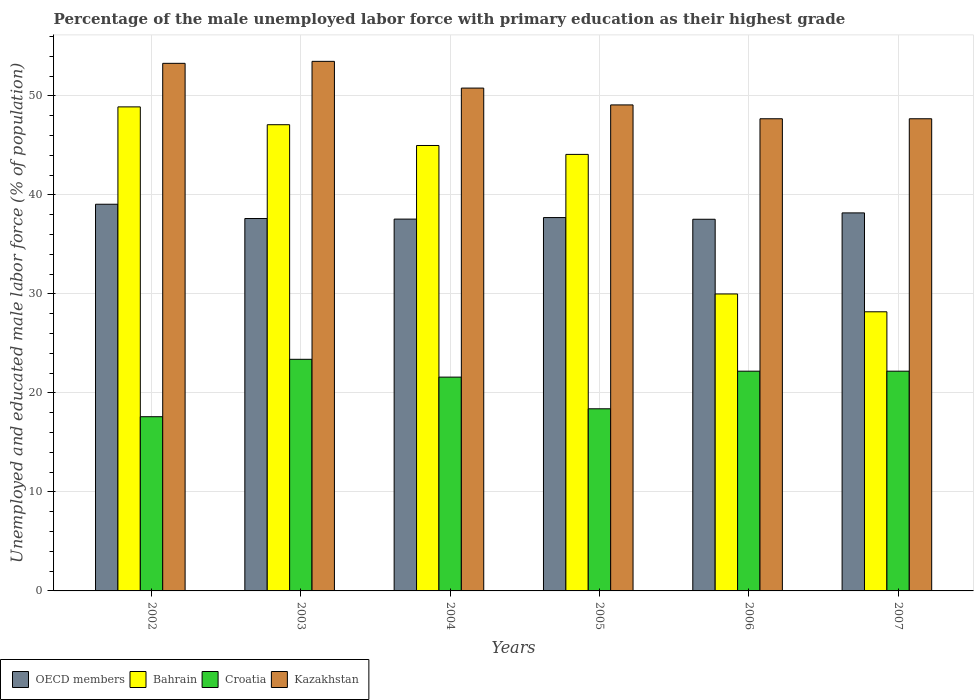How many groups of bars are there?
Your answer should be compact. 6. Are the number of bars per tick equal to the number of legend labels?
Your response must be concise. Yes. How many bars are there on the 6th tick from the left?
Provide a succinct answer. 4. How many bars are there on the 4th tick from the right?
Provide a succinct answer. 4. What is the label of the 2nd group of bars from the left?
Make the answer very short. 2003. What is the percentage of the unemployed male labor force with primary education in Kazakhstan in 2006?
Provide a short and direct response. 47.7. Across all years, what is the maximum percentage of the unemployed male labor force with primary education in Bahrain?
Give a very brief answer. 48.9. Across all years, what is the minimum percentage of the unemployed male labor force with primary education in Kazakhstan?
Your answer should be compact. 47.7. In which year was the percentage of the unemployed male labor force with primary education in Bahrain minimum?
Offer a very short reply. 2007. What is the total percentage of the unemployed male labor force with primary education in OECD members in the graph?
Ensure brevity in your answer.  227.71. What is the difference between the percentage of the unemployed male labor force with primary education in Bahrain in 2006 and that in 2007?
Provide a succinct answer. 1.8. What is the difference between the percentage of the unemployed male labor force with primary education in Bahrain in 2007 and the percentage of the unemployed male labor force with primary education in Kazakhstan in 2002?
Ensure brevity in your answer.  -25.1. What is the average percentage of the unemployed male labor force with primary education in Croatia per year?
Make the answer very short. 20.9. In the year 2003, what is the difference between the percentage of the unemployed male labor force with primary education in Kazakhstan and percentage of the unemployed male labor force with primary education in Bahrain?
Give a very brief answer. 6.4. In how many years, is the percentage of the unemployed male labor force with primary education in Kazakhstan greater than 2 %?
Provide a succinct answer. 6. What is the ratio of the percentage of the unemployed male labor force with primary education in Bahrain in 2004 to that in 2005?
Keep it short and to the point. 1.02. Is the percentage of the unemployed male labor force with primary education in Croatia in 2004 less than that in 2007?
Offer a terse response. Yes. Is the difference between the percentage of the unemployed male labor force with primary education in Kazakhstan in 2002 and 2005 greater than the difference between the percentage of the unemployed male labor force with primary education in Bahrain in 2002 and 2005?
Your answer should be compact. No. What is the difference between the highest and the second highest percentage of the unemployed male labor force with primary education in Croatia?
Offer a terse response. 1.2. What is the difference between the highest and the lowest percentage of the unemployed male labor force with primary education in Croatia?
Offer a terse response. 5.8. Is the sum of the percentage of the unemployed male labor force with primary education in Bahrain in 2004 and 2005 greater than the maximum percentage of the unemployed male labor force with primary education in Kazakhstan across all years?
Offer a terse response. Yes. Is it the case that in every year, the sum of the percentage of the unemployed male labor force with primary education in OECD members and percentage of the unemployed male labor force with primary education in Bahrain is greater than the sum of percentage of the unemployed male labor force with primary education in Kazakhstan and percentage of the unemployed male labor force with primary education in Croatia?
Offer a very short reply. No. What does the 4th bar from the left in 2002 represents?
Provide a succinct answer. Kazakhstan. What does the 1st bar from the right in 2006 represents?
Provide a succinct answer. Kazakhstan. Is it the case that in every year, the sum of the percentage of the unemployed male labor force with primary education in Croatia and percentage of the unemployed male labor force with primary education in Bahrain is greater than the percentage of the unemployed male labor force with primary education in OECD members?
Give a very brief answer. Yes. How many years are there in the graph?
Your response must be concise. 6. What is the difference between two consecutive major ticks on the Y-axis?
Offer a terse response. 10. Are the values on the major ticks of Y-axis written in scientific E-notation?
Make the answer very short. No. Does the graph contain grids?
Provide a short and direct response. Yes. How many legend labels are there?
Your answer should be very brief. 4. How are the legend labels stacked?
Keep it short and to the point. Horizontal. What is the title of the graph?
Ensure brevity in your answer.  Percentage of the male unemployed labor force with primary education as their highest grade. What is the label or title of the X-axis?
Offer a very short reply. Years. What is the label or title of the Y-axis?
Make the answer very short. Unemployed and educated male labor force (% of population). What is the Unemployed and educated male labor force (% of population) in OECD members in 2002?
Offer a very short reply. 39.06. What is the Unemployed and educated male labor force (% of population) in Bahrain in 2002?
Offer a very short reply. 48.9. What is the Unemployed and educated male labor force (% of population) in Croatia in 2002?
Ensure brevity in your answer.  17.6. What is the Unemployed and educated male labor force (% of population) of Kazakhstan in 2002?
Provide a succinct answer. 53.3. What is the Unemployed and educated male labor force (% of population) in OECD members in 2003?
Provide a short and direct response. 37.62. What is the Unemployed and educated male labor force (% of population) of Bahrain in 2003?
Offer a very short reply. 47.1. What is the Unemployed and educated male labor force (% of population) of Croatia in 2003?
Your answer should be compact. 23.4. What is the Unemployed and educated male labor force (% of population) in Kazakhstan in 2003?
Your answer should be very brief. 53.5. What is the Unemployed and educated male labor force (% of population) in OECD members in 2004?
Make the answer very short. 37.56. What is the Unemployed and educated male labor force (% of population) of Croatia in 2004?
Your response must be concise. 21.6. What is the Unemployed and educated male labor force (% of population) in Kazakhstan in 2004?
Offer a very short reply. 50.8. What is the Unemployed and educated male labor force (% of population) in OECD members in 2005?
Provide a short and direct response. 37.72. What is the Unemployed and educated male labor force (% of population) of Bahrain in 2005?
Your answer should be very brief. 44.1. What is the Unemployed and educated male labor force (% of population) of Croatia in 2005?
Provide a succinct answer. 18.4. What is the Unemployed and educated male labor force (% of population) in Kazakhstan in 2005?
Offer a terse response. 49.1. What is the Unemployed and educated male labor force (% of population) of OECD members in 2006?
Keep it short and to the point. 37.55. What is the Unemployed and educated male labor force (% of population) of Croatia in 2006?
Ensure brevity in your answer.  22.2. What is the Unemployed and educated male labor force (% of population) in Kazakhstan in 2006?
Your answer should be compact. 47.7. What is the Unemployed and educated male labor force (% of population) in OECD members in 2007?
Provide a short and direct response. 38.19. What is the Unemployed and educated male labor force (% of population) in Bahrain in 2007?
Provide a succinct answer. 28.2. What is the Unemployed and educated male labor force (% of population) of Croatia in 2007?
Keep it short and to the point. 22.2. What is the Unemployed and educated male labor force (% of population) in Kazakhstan in 2007?
Keep it short and to the point. 47.7. Across all years, what is the maximum Unemployed and educated male labor force (% of population) in OECD members?
Ensure brevity in your answer.  39.06. Across all years, what is the maximum Unemployed and educated male labor force (% of population) in Bahrain?
Your answer should be very brief. 48.9. Across all years, what is the maximum Unemployed and educated male labor force (% of population) in Croatia?
Make the answer very short. 23.4. Across all years, what is the maximum Unemployed and educated male labor force (% of population) in Kazakhstan?
Make the answer very short. 53.5. Across all years, what is the minimum Unemployed and educated male labor force (% of population) of OECD members?
Ensure brevity in your answer.  37.55. Across all years, what is the minimum Unemployed and educated male labor force (% of population) of Bahrain?
Your answer should be compact. 28.2. Across all years, what is the minimum Unemployed and educated male labor force (% of population) of Croatia?
Make the answer very short. 17.6. Across all years, what is the minimum Unemployed and educated male labor force (% of population) of Kazakhstan?
Give a very brief answer. 47.7. What is the total Unemployed and educated male labor force (% of population) of OECD members in the graph?
Make the answer very short. 227.71. What is the total Unemployed and educated male labor force (% of population) in Bahrain in the graph?
Your answer should be very brief. 243.3. What is the total Unemployed and educated male labor force (% of population) in Croatia in the graph?
Keep it short and to the point. 125.4. What is the total Unemployed and educated male labor force (% of population) in Kazakhstan in the graph?
Offer a terse response. 302.1. What is the difference between the Unemployed and educated male labor force (% of population) of OECD members in 2002 and that in 2003?
Your answer should be compact. 1.44. What is the difference between the Unemployed and educated male labor force (% of population) in Bahrain in 2002 and that in 2003?
Your answer should be very brief. 1.8. What is the difference between the Unemployed and educated male labor force (% of population) in OECD members in 2002 and that in 2004?
Your answer should be very brief. 1.5. What is the difference between the Unemployed and educated male labor force (% of population) of Croatia in 2002 and that in 2004?
Your answer should be compact. -4. What is the difference between the Unemployed and educated male labor force (% of population) of Kazakhstan in 2002 and that in 2004?
Ensure brevity in your answer.  2.5. What is the difference between the Unemployed and educated male labor force (% of population) in OECD members in 2002 and that in 2005?
Provide a succinct answer. 1.35. What is the difference between the Unemployed and educated male labor force (% of population) of Bahrain in 2002 and that in 2005?
Give a very brief answer. 4.8. What is the difference between the Unemployed and educated male labor force (% of population) of Croatia in 2002 and that in 2005?
Ensure brevity in your answer.  -0.8. What is the difference between the Unemployed and educated male labor force (% of population) in OECD members in 2002 and that in 2006?
Ensure brevity in your answer.  1.52. What is the difference between the Unemployed and educated male labor force (% of population) in Bahrain in 2002 and that in 2006?
Provide a succinct answer. 18.9. What is the difference between the Unemployed and educated male labor force (% of population) of Kazakhstan in 2002 and that in 2006?
Your answer should be compact. 5.6. What is the difference between the Unemployed and educated male labor force (% of population) in OECD members in 2002 and that in 2007?
Ensure brevity in your answer.  0.87. What is the difference between the Unemployed and educated male labor force (% of population) of Bahrain in 2002 and that in 2007?
Provide a succinct answer. 20.7. What is the difference between the Unemployed and educated male labor force (% of population) in Kazakhstan in 2002 and that in 2007?
Give a very brief answer. 5.6. What is the difference between the Unemployed and educated male labor force (% of population) in OECD members in 2003 and that in 2004?
Your answer should be compact. 0.06. What is the difference between the Unemployed and educated male labor force (% of population) of OECD members in 2003 and that in 2005?
Provide a short and direct response. -0.1. What is the difference between the Unemployed and educated male labor force (% of population) in Bahrain in 2003 and that in 2005?
Provide a succinct answer. 3. What is the difference between the Unemployed and educated male labor force (% of population) of OECD members in 2003 and that in 2006?
Keep it short and to the point. 0.07. What is the difference between the Unemployed and educated male labor force (% of population) in Kazakhstan in 2003 and that in 2006?
Offer a terse response. 5.8. What is the difference between the Unemployed and educated male labor force (% of population) in OECD members in 2003 and that in 2007?
Make the answer very short. -0.57. What is the difference between the Unemployed and educated male labor force (% of population) of Bahrain in 2003 and that in 2007?
Provide a short and direct response. 18.9. What is the difference between the Unemployed and educated male labor force (% of population) of OECD members in 2004 and that in 2005?
Keep it short and to the point. -0.16. What is the difference between the Unemployed and educated male labor force (% of population) in OECD members in 2004 and that in 2006?
Offer a terse response. 0.02. What is the difference between the Unemployed and educated male labor force (% of population) in Bahrain in 2004 and that in 2006?
Your answer should be compact. 15. What is the difference between the Unemployed and educated male labor force (% of population) in Kazakhstan in 2004 and that in 2006?
Your answer should be very brief. 3.1. What is the difference between the Unemployed and educated male labor force (% of population) in OECD members in 2004 and that in 2007?
Offer a very short reply. -0.63. What is the difference between the Unemployed and educated male labor force (% of population) in Bahrain in 2004 and that in 2007?
Your answer should be compact. 16.8. What is the difference between the Unemployed and educated male labor force (% of population) in Kazakhstan in 2004 and that in 2007?
Your answer should be compact. 3.1. What is the difference between the Unemployed and educated male labor force (% of population) of OECD members in 2005 and that in 2006?
Offer a very short reply. 0.17. What is the difference between the Unemployed and educated male labor force (% of population) of Bahrain in 2005 and that in 2006?
Provide a short and direct response. 14.1. What is the difference between the Unemployed and educated male labor force (% of population) in Kazakhstan in 2005 and that in 2006?
Your answer should be compact. 1.4. What is the difference between the Unemployed and educated male labor force (% of population) of OECD members in 2005 and that in 2007?
Your answer should be compact. -0.47. What is the difference between the Unemployed and educated male labor force (% of population) of OECD members in 2006 and that in 2007?
Your answer should be very brief. -0.64. What is the difference between the Unemployed and educated male labor force (% of population) of Bahrain in 2006 and that in 2007?
Offer a terse response. 1.8. What is the difference between the Unemployed and educated male labor force (% of population) in Croatia in 2006 and that in 2007?
Ensure brevity in your answer.  0. What is the difference between the Unemployed and educated male labor force (% of population) of Kazakhstan in 2006 and that in 2007?
Offer a very short reply. 0. What is the difference between the Unemployed and educated male labor force (% of population) of OECD members in 2002 and the Unemployed and educated male labor force (% of population) of Bahrain in 2003?
Offer a terse response. -8.04. What is the difference between the Unemployed and educated male labor force (% of population) of OECD members in 2002 and the Unemployed and educated male labor force (% of population) of Croatia in 2003?
Your answer should be very brief. 15.66. What is the difference between the Unemployed and educated male labor force (% of population) of OECD members in 2002 and the Unemployed and educated male labor force (% of population) of Kazakhstan in 2003?
Your answer should be very brief. -14.44. What is the difference between the Unemployed and educated male labor force (% of population) of Bahrain in 2002 and the Unemployed and educated male labor force (% of population) of Kazakhstan in 2003?
Offer a terse response. -4.6. What is the difference between the Unemployed and educated male labor force (% of population) in Croatia in 2002 and the Unemployed and educated male labor force (% of population) in Kazakhstan in 2003?
Offer a very short reply. -35.9. What is the difference between the Unemployed and educated male labor force (% of population) of OECD members in 2002 and the Unemployed and educated male labor force (% of population) of Bahrain in 2004?
Make the answer very short. -5.94. What is the difference between the Unemployed and educated male labor force (% of population) in OECD members in 2002 and the Unemployed and educated male labor force (% of population) in Croatia in 2004?
Your answer should be compact. 17.46. What is the difference between the Unemployed and educated male labor force (% of population) in OECD members in 2002 and the Unemployed and educated male labor force (% of population) in Kazakhstan in 2004?
Give a very brief answer. -11.74. What is the difference between the Unemployed and educated male labor force (% of population) in Bahrain in 2002 and the Unemployed and educated male labor force (% of population) in Croatia in 2004?
Your answer should be compact. 27.3. What is the difference between the Unemployed and educated male labor force (% of population) in Bahrain in 2002 and the Unemployed and educated male labor force (% of population) in Kazakhstan in 2004?
Your answer should be compact. -1.9. What is the difference between the Unemployed and educated male labor force (% of population) of Croatia in 2002 and the Unemployed and educated male labor force (% of population) of Kazakhstan in 2004?
Your response must be concise. -33.2. What is the difference between the Unemployed and educated male labor force (% of population) in OECD members in 2002 and the Unemployed and educated male labor force (% of population) in Bahrain in 2005?
Your answer should be very brief. -5.04. What is the difference between the Unemployed and educated male labor force (% of population) in OECD members in 2002 and the Unemployed and educated male labor force (% of population) in Croatia in 2005?
Provide a succinct answer. 20.66. What is the difference between the Unemployed and educated male labor force (% of population) in OECD members in 2002 and the Unemployed and educated male labor force (% of population) in Kazakhstan in 2005?
Give a very brief answer. -10.04. What is the difference between the Unemployed and educated male labor force (% of population) in Bahrain in 2002 and the Unemployed and educated male labor force (% of population) in Croatia in 2005?
Make the answer very short. 30.5. What is the difference between the Unemployed and educated male labor force (% of population) in Bahrain in 2002 and the Unemployed and educated male labor force (% of population) in Kazakhstan in 2005?
Offer a terse response. -0.2. What is the difference between the Unemployed and educated male labor force (% of population) of Croatia in 2002 and the Unemployed and educated male labor force (% of population) of Kazakhstan in 2005?
Make the answer very short. -31.5. What is the difference between the Unemployed and educated male labor force (% of population) in OECD members in 2002 and the Unemployed and educated male labor force (% of population) in Bahrain in 2006?
Your answer should be very brief. 9.06. What is the difference between the Unemployed and educated male labor force (% of population) of OECD members in 2002 and the Unemployed and educated male labor force (% of population) of Croatia in 2006?
Make the answer very short. 16.86. What is the difference between the Unemployed and educated male labor force (% of population) in OECD members in 2002 and the Unemployed and educated male labor force (% of population) in Kazakhstan in 2006?
Give a very brief answer. -8.64. What is the difference between the Unemployed and educated male labor force (% of population) of Bahrain in 2002 and the Unemployed and educated male labor force (% of population) of Croatia in 2006?
Give a very brief answer. 26.7. What is the difference between the Unemployed and educated male labor force (% of population) of Croatia in 2002 and the Unemployed and educated male labor force (% of population) of Kazakhstan in 2006?
Provide a succinct answer. -30.1. What is the difference between the Unemployed and educated male labor force (% of population) of OECD members in 2002 and the Unemployed and educated male labor force (% of population) of Bahrain in 2007?
Offer a terse response. 10.86. What is the difference between the Unemployed and educated male labor force (% of population) in OECD members in 2002 and the Unemployed and educated male labor force (% of population) in Croatia in 2007?
Your answer should be very brief. 16.86. What is the difference between the Unemployed and educated male labor force (% of population) of OECD members in 2002 and the Unemployed and educated male labor force (% of population) of Kazakhstan in 2007?
Your answer should be very brief. -8.64. What is the difference between the Unemployed and educated male labor force (% of population) of Bahrain in 2002 and the Unemployed and educated male labor force (% of population) of Croatia in 2007?
Make the answer very short. 26.7. What is the difference between the Unemployed and educated male labor force (% of population) of Bahrain in 2002 and the Unemployed and educated male labor force (% of population) of Kazakhstan in 2007?
Make the answer very short. 1.2. What is the difference between the Unemployed and educated male labor force (% of population) of Croatia in 2002 and the Unemployed and educated male labor force (% of population) of Kazakhstan in 2007?
Offer a very short reply. -30.1. What is the difference between the Unemployed and educated male labor force (% of population) in OECD members in 2003 and the Unemployed and educated male labor force (% of population) in Bahrain in 2004?
Provide a short and direct response. -7.38. What is the difference between the Unemployed and educated male labor force (% of population) of OECD members in 2003 and the Unemployed and educated male labor force (% of population) of Croatia in 2004?
Make the answer very short. 16.02. What is the difference between the Unemployed and educated male labor force (% of population) of OECD members in 2003 and the Unemployed and educated male labor force (% of population) of Kazakhstan in 2004?
Make the answer very short. -13.18. What is the difference between the Unemployed and educated male labor force (% of population) in Bahrain in 2003 and the Unemployed and educated male labor force (% of population) in Croatia in 2004?
Make the answer very short. 25.5. What is the difference between the Unemployed and educated male labor force (% of population) of Croatia in 2003 and the Unemployed and educated male labor force (% of population) of Kazakhstan in 2004?
Ensure brevity in your answer.  -27.4. What is the difference between the Unemployed and educated male labor force (% of population) in OECD members in 2003 and the Unemployed and educated male labor force (% of population) in Bahrain in 2005?
Your answer should be compact. -6.48. What is the difference between the Unemployed and educated male labor force (% of population) in OECD members in 2003 and the Unemployed and educated male labor force (% of population) in Croatia in 2005?
Keep it short and to the point. 19.22. What is the difference between the Unemployed and educated male labor force (% of population) of OECD members in 2003 and the Unemployed and educated male labor force (% of population) of Kazakhstan in 2005?
Make the answer very short. -11.48. What is the difference between the Unemployed and educated male labor force (% of population) in Bahrain in 2003 and the Unemployed and educated male labor force (% of population) in Croatia in 2005?
Provide a short and direct response. 28.7. What is the difference between the Unemployed and educated male labor force (% of population) of Croatia in 2003 and the Unemployed and educated male labor force (% of population) of Kazakhstan in 2005?
Make the answer very short. -25.7. What is the difference between the Unemployed and educated male labor force (% of population) of OECD members in 2003 and the Unemployed and educated male labor force (% of population) of Bahrain in 2006?
Offer a very short reply. 7.62. What is the difference between the Unemployed and educated male labor force (% of population) in OECD members in 2003 and the Unemployed and educated male labor force (% of population) in Croatia in 2006?
Offer a terse response. 15.42. What is the difference between the Unemployed and educated male labor force (% of population) of OECD members in 2003 and the Unemployed and educated male labor force (% of population) of Kazakhstan in 2006?
Your answer should be compact. -10.08. What is the difference between the Unemployed and educated male labor force (% of population) in Bahrain in 2003 and the Unemployed and educated male labor force (% of population) in Croatia in 2006?
Your answer should be very brief. 24.9. What is the difference between the Unemployed and educated male labor force (% of population) of Bahrain in 2003 and the Unemployed and educated male labor force (% of population) of Kazakhstan in 2006?
Ensure brevity in your answer.  -0.6. What is the difference between the Unemployed and educated male labor force (% of population) in Croatia in 2003 and the Unemployed and educated male labor force (% of population) in Kazakhstan in 2006?
Your answer should be compact. -24.3. What is the difference between the Unemployed and educated male labor force (% of population) of OECD members in 2003 and the Unemployed and educated male labor force (% of population) of Bahrain in 2007?
Ensure brevity in your answer.  9.42. What is the difference between the Unemployed and educated male labor force (% of population) of OECD members in 2003 and the Unemployed and educated male labor force (% of population) of Croatia in 2007?
Offer a terse response. 15.42. What is the difference between the Unemployed and educated male labor force (% of population) of OECD members in 2003 and the Unemployed and educated male labor force (% of population) of Kazakhstan in 2007?
Provide a short and direct response. -10.08. What is the difference between the Unemployed and educated male labor force (% of population) in Bahrain in 2003 and the Unemployed and educated male labor force (% of population) in Croatia in 2007?
Give a very brief answer. 24.9. What is the difference between the Unemployed and educated male labor force (% of population) of Bahrain in 2003 and the Unemployed and educated male labor force (% of population) of Kazakhstan in 2007?
Your answer should be compact. -0.6. What is the difference between the Unemployed and educated male labor force (% of population) in Croatia in 2003 and the Unemployed and educated male labor force (% of population) in Kazakhstan in 2007?
Give a very brief answer. -24.3. What is the difference between the Unemployed and educated male labor force (% of population) in OECD members in 2004 and the Unemployed and educated male labor force (% of population) in Bahrain in 2005?
Provide a succinct answer. -6.54. What is the difference between the Unemployed and educated male labor force (% of population) in OECD members in 2004 and the Unemployed and educated male labor force (% of population) in Croatia in 2005?
Your response must be concise. 19.16. What is the difference between the Unemployed and educated male labor force (% of population) in OECD members in 2004 and the Unemployed and educated male labor force (% of population) in Kazakhstan in 2005?
Give a very brief answer. -11.54. What is the difference between the Unemployed and educated male labor force (% of population) of Bahrain in 2004 and the Unemployed and educated male labor force (% of population) of Croatia in 2005?
Your answer should be compact. 26.6. What is the difference between the Unemployed and educated male labor force (% of population) in Croatia in 2004 and the Unemployed and educated male labor force (% of population) in Kazakhstan in 2005?
Give a very brief answer. -27.5. What is the difference between the Unemployed and educated male labor force (% of population) of OECD members in 2004 and the Unemployed and educated male labor force (% of population) of Bahrain in 2006?
Make the answer very short. 7.56. What is the difference between the Unemployed and educated male labor force (% of population) of OECD members in 2004 and the Unemployed and educated male labor force (% of population) of Croatia in 2006?
Your answer should be very brief. 15.36. What is the difference between the Unemployed and educated male labor force (% of population) in OECD members in 2004 and the Unemployed and educated male labor force (% of population) in Kazakhstan in 2006?
Ensure brevity in your answer.  -10.14. What is the difference between the Unemployed and educated male labor force (% of population) in Bahrain in 2004 and the Unemployed and educated male labor force (% of population) in Croatia in 2006?
Offer a terse response. 22.8. What is the difference between the Unemployed and educated male labor force (% of population) of Croatia in 2004 and the Unemployed and educated male labor force (% of population) of Kazakhstan in 2006?
Your answer should be very brief. -26.1. What is the difference between the Unemployed and educated male labor force (% of population) of OECD members in 2004 and the Unemployed and educated male labor force (% of population) of Bahrain in 2007?
Provide a succinct answer. 9.36. What is the difference between the Unemployed and educated male labor force (% of population) in OECD members in 2004 and the Unemployed and educated male labor force (% of population) in Croatia in 2007?
Offer a very short reply. 15.36. What is the difference between the Unemployed and educated male labor force (% of population) of OECD members in 2004 and the Unemployed and educated male labor force (% of population) of Kazakhstan in 2007?
Keep it short and to the point. -10.14. What is the difference between the Unemployed and educated male labor force (% of population) in Bahrain in 2004 and the Unemployed and educated male labor force (% of population) in Croatia in 2007?
Keep it short and to the point. 22.8. What is the difference between the Unemployed and educated male labor force (% of population) in Bahrain in 2004 and the Unemployed and educated male labor force (% of population) in Kazakhstan in 2007?
Offer a terse response. -2.7. What is the difference between the Unemployed and educated male labor force (% of population) in Croatia in 2004 and the Unemployed and educated male labor force (% of population) in Kazakhstan in 2007?
Keep it short and to the point. -26.1. What is the difference between the Unemployed and educated male labor force (% of population) in OECD members in 2005 and the Unemployed and educated male labor force (% of population) in Bahrain in 2006?
Your response must be concise. 7.72. What is the difference between the Unemployed and educated male labor force (% of population) of OECD members in 2005 and the Unemployed and educated male labor force (% of population) of Croatia in 2006?
Offer a very short reply. 15.52. What is the difference between the Unemployed and educated male labor force (% of population) in OECD members in 2005 and the Unemployed and educated male labor force (% of population) in Kazakhstan in 2006?
Ensure brevity in your answer.  -9.98. What is the difference between the Unemployed and educated male labor force (% of population) of Bahrain in 2005 and the Unemployed and educated male labor force (% of population) of Croatia in 2006?
Give a very brief answer. 21.9. What is the difference between the Unemployed and educated male labor force (% of population) of Bahrain in 2005 and the Unemployed and educated male labor force (% of population) of Kazakhstan in 2006?
Give a very brief answer. -3.6. What is the difference between the Unemployed and educated male labor force (% of population) of Croatia in 2005 and the Unemployed and educated male labor force (% of population) of Kazakhstan in 2006?
Offer a terse response. -29.3. What is the difference between the Unemployed and educated male labor force (% of population) of OECD members in 2005 and the Unemployed and educated male labor force (% of population) of Bahrain in 2007?
Provide a succinct answer. 9.52. What is the difference between the Unemployed and educated male labor force (% of population) of OECD members in 2005 and the Unemployed and educated male labor force (% of population) of Croatia in 2007?
Your answer should be compact. 15.52. What is the difference between the Unemployed and educated male labor force (% of population) of OECD members in 2005 and the Unemployed and educated male labor force (% of population) of Kazakhstan in 2007?
Give a very brief answer. -9.98. What is the difference between the Unemployed and educated male labor force (% of population) of Bahrain in 2005 and the Unemployed and educated male labor force (% of population) of Croatia in 2007?
Ensure brevity in your answer.  21.9. What is the difference between the Unemployed and educated male labor force (% of population) in Bahrain in 2005 and the Unemployed and educated male labor force (% of population) in Kazakhstan in 2007?
Your answer should be very brief. -3.6. What is the difference between the Unemployed and educated male labor force (% of population) in Croatia in 2005 and the Unemployed and educated male labor force (% of population) in Kazakhstan in 2007?
Your answer should be compact. -29.3. What is the difference between the Unemployed and educated male labor force (% of population) of OECD members in 2006 and the Unemployed and educated male labor force (% of population) of Bahrain in 2007?
Provide a succinct answer. 9.35. What is the difference between the Unemployed and educated male labor force (% of population) in OECD members in 2006 and the Unemployed and educated male labor force (% of population) in Croatia in 2007?
Your answer should be compact. 15.35. What is the difference between the Unemployed and educated male labor force (% of population) of OECD members in 2006 and the Unemployed and educated male labor force (% of population) of Kazakhstan in 2007?
Your answer should be compact. -10.15. What is the difference between the Unemployed and educated male labor force (% of population) in Bahrain in 2006 and the Unemployed and educated male labor force (% of population) in Croatia in 2007?
Keep it short and to the point. 7.8. What is the difference between the Unemployed and educated male labor force (% of population) in Bahrain in 2006 and the Unemployed and educated male labor force (% of population) in Kazakhstan in 2007?
Keep it short and to the point. -17.7. What is the difference between the Unemployed and educated male labor force (% of population) in Croatia in 2006 and the Unemployed and educated male labor force (% of population) in Kazakhstan in 2007?
Your response must be concise. -25.5. What is the average Unemployed and educated male labor force (% of population) in OECD members per year?
Keep it short and to the point. 37.95. What is the average Unemployed and educated male labor force (% of population) in Bahrain per year?
Offer a terse response. 40.55. What is the average Unemployed and educated male labor force (% of population) of Croatia per year?
Provide a succinct answer. 20.9. What is the average Unemployed and educated male labor force (% of population) in Kazakhstan per year?
Provide a succinct answer. 50.35. In the year 2002, what is the difference between the Unemployed and educated male labor force (% of population) of OECD members and Unemployed and educated male labor force (% of population) of Bahrain?
Your response must be concise. -9.84. In the year 2002, what is the difference between the Unemployed and educated male labor force (% of population) in OECD members and Unemployed and educated male labor force (% of population) in Croatia?
Give a very brief answer. 21.46. In the year 2002, what is the difference between the Unemployed and educated male labor force (% of population) in OECD members and Unemployed and educated male labor force (% of population) in Kazakhstan?
Your answer should be compact. -14.24. In the year 2002, what is the difference between the Unemployed and educated male labor force (% of population) of Bahrain and Unemployed and educated male labor force (% of population) of Croatia?
Your response must be concise. 31.3. In the year 2002, what is the difference between the Unemployed and educated male labor force (% of population) of Croatia and Unemployed and educated male labor force (% of population) of Kazakhstan?
Offer a terse response. -35.7. In the year 2003, what is the difference between the Unemployed and educated male labor force (% of population) of OECD members and Unemployed and educated male labor force (% of population) of Bahrain?
Provide a short and direct response. -9.48. In the year 2003, what is the difference between the Unemployed and educated male labor force (% of population) of OECD members and Unemployed and educated male labor force (% of population) of Croatia?
Ensure brevity in your answer.  14.22. In the year 2003, what is the difference between the Unemployed and educated male labor force (% of population) of OECD members and Unemployed and educated male labor force (% of population) of Kazakhstan?
Keep it short and to the point. -15.88. In the year 2003, what is the difference between the Unemployed and educated male labor force (% of population) in Bahrain and Unemployed and educated male labor force (% of population) in Croatia?
Provide a short and direct response. 23.7. In the year 2003, what is the difference between the Unemployed and educated male labor force (% of population) in Croatia and Unemployed and educated male labor force (% of population) in Kazakhstan?
Provide a succinct answer. -30.1. In the year 2004, what is the difference between the Unemployed and educated male labor force (% of population) of OECD members and Unemployed and educated male labor force (% of population) of Bahrain?
Provide a short and direct response. -7.44. In the year 2004, what is the difference between the Unemployed and educated male labor force (% of population) in OECD members and Unemployed and educated male labor force (% of population) in Croatia?
Your answer should be very brief. 15.96. In the year 2004, what is the difference between the Unemployed and educated male labor force (% of population) of OECD members and Unemployed and educated male labor force (% of population) of Kazakhstan?
Your answer should be compact. -13.24. In the year 2004, what is the difference between the Unemployed and educated male labor force (% of population) of Bahrain and Unemployed and educated male labor force (% of population) of Croatia?
Your answer should be very brief. 23.4. In the year 2004, what is the difference between the Unemployed and educated male labor force (% of population) in Bahrain and Unemployed and educated male labor force (% of population) in Kazakhstan?
Ensure brevity in your answer.  -5.8. In the year 2004, what is the difference between the Unemployed and educated male labor force (% of population) in Croatia and Unemployed and educated male labor force (% of population) in Kazakhstan?
Ensure brevity in your answer.  -29.2. In the year 2005, what is the difference between the Unemployed and educated male labor force (% of population) of OECD members and Unemployed and educated male labor force (% of population) of Bahrain?
Keep it short and to the point. -6.38. In the year 2005, what is the difference between the Unemployed and educated male labor force (% of population) in OECD members and Unemployed and educated male labor force (% of population) in Croatia?
Keep it short and to the point. 19.32. In the year 2005, what is the difference between the Unemployed and educated male labor force (% of population) of OECD members and Unemployed and educated male labor force (% of population) of Kazakhstan?
Offer a very short reply. -11.38. In the year 2005, what is the difference between the Unemployed and educated male labor force (% of population) of Bahrain and Unemployed and educated male labor force (% of population) of Croatia?
Provide a short and direct response. 25.7. In the year 2005, what is the difference between the Unemployed and educated male labor force (% of population) of Croatia and Unemployed and educated male labor force (% of population) of Kazakhstan?
Offer a very short reply. -30.7. In the year 2006, what is the difference between the Unemployed and educated male labor force (% of population) in OECD members and Unemployed and educated male labor force (% of population) in Bahrain?
Your answer should be very brief. 7.55. In the year 2006, what is the difference between the Unemployed and educated male labor force (% of population) in OECD members and Unemployed and educated male labor force (% of population) in Croatia?
Offer a very short reply. 15.35. In the year 2006, what is the difference between the Unemployed and educated male labor force (% of population) in OECD members and Unemployed and educated male labor force (% of population) in Kazakhstan?
Your answer should be compact. -10.15. In the year 2006, what is the difference between the Unemployed and educated male labor force (% of population) of Bahrain and Unemployed and educated male labor force (% of population) of Kazakhstan?
Give a very brief answer. -17.7. In the year 2006, what is the difference between the Unemployed and educated male labor force (% of population) of Croatia and Unemployed and educated male labor force (% of population) of Kazakhstan?
Your answer should be very brief. -25.5. In the year 2007, what is the difference between the Unemployed and educated male labor force (% of population) in OECD members and Unemployed and educated male labor force (% of population) in Bahrain?
Offer a terse response. 9.99. In the year 2007, what is the difference between the Unemployed and educated male labor force (% of population) of OECD members and Unemployed and educated male labor force (% of population) of Croatia?
Make the answer very short. 15.99. In the year 2007, what is the difference between the Unemployed and educated male labor force (% of population) of OECD members and Unemployed and educated male labor force (% of population) of Kazakhstan?
Offer a very short reply. -9.51. In the year 2007, what is the difference between the Unemployed and educated male labor force (% of population) in Bahrain and Unemployed and educated male labor force (% of population) in Croatia?
Your answer should be very brief. 6. In the year 2007, what is the difference between the Unemployed and educated male labor force (% of population) of Bahrain and Unemployed and educated male labor force (% of population) of Kazakhstan?
Your answer should be very brief. -19.5. In the year 2007, what is the difference between the Unemployed and educated male labor force (% of population) in Croatia and Unemployed and educated male labor force (% of population) in Kazakhstan?
Offer a very short reply. -25.5. What is the ratio of the Unemployed and educated male labor force (% of population) in OECD members in 2002 to that in 2003?
Make the answer very short. 1.04. What is the ratio of the Unemployed and educated male labor force (% of population) in Bahrain in 2002 to that in 2003?
Give a very brief answer. 1.04. What is the ratio of the Unemployed and educated male labor force (% of population) of Croatia in 2002 to that in 2003?
Keep it short and to the point. 0.75. What is the ratio of the Unemployed and educated male labor force (% of population) of Bahrain in 2002 to that in 2004?
Provide a succinct answer. 1.09. What is the ratio of the Unemployed and educated male labor force (% of population) of Croatia in 2002 to that in 2004?
Keep it short and to the point. 0.81. What is the ratio of the Unemployed and educated male labor force (% of population) of Kazakhstan in 2002 to that in 2004?
Your answer should be very brief. 1.05. What is the ratio of the Unemployed and educated male labor force (% of population) of OECD members in 2002 to that in 2005?
Provide a succinct answer. 1.04. What is the ratio of the Unemployed and educated male labor force (% of population) of Bahrain in 2002 to that in 2005?
Provide a short and direct response. 1.11. What is the ratio of the Unemployed and educated male labor force (% of population) in Croatia in 2002 to that in 2005?
Offer a terse response. 0.96. What is the ratio of the Unemployed and educated male labor force (% of population) of Kazakhstan in 2002 to that in 2005?
Offer a terse response. 1.09. What is the ratio of the Unemployed and educated male labor force (% of population) in OECD members in 2002 to that in 2006?
Provide a short and direct response. 1.04. What is the ratio of the Unemployed and educated male labor force (% of population) of Bahrain in 2002 to that in 2006?
Your answer should be very brief. 1.63. What is the ratio of the Unemployed and educated male labor force (% of population) of Croatia in 2002 to that in 2006?
Provide a succinct answer. 0.79. What is the ratio of the Unemployed and educated male labor force (% of population) in Kazakhstan in 2002 to that in 2006?
Offer a very short reply. 1.12. What is the ratio of the Unemployed and educated male labor force (% of population) in OECD members in 2002 to that in 2007?
Make the answer very short. 1.02. What is the ratio of the Unemployed and educated male labor force (% of population) of Bahrain in 2002 to that in 2007?
Provide a succinct answer. 1.73. What is the ratio of the Unemployed and educated male labor force (% of population) of Croatia in 2002 to that in 2007?
Give a very brief answer. 0.79. What is the ratio of the Unemployed and educated male labor force (% of population) in Kazakhstan in 2002 to that in 2007?
Your answer should be very brief. 1.12. What is the ratio of the Unemployed and educated male labor force (% of population) in Bahrain in 2003 to that in 2004?
Offer a terse response. 1.05. What is the ratio of the Unemployed and educated male labor force (% of population) of Kazakhstan in 2003 to that in 2004?
Offer a terse response. 1.05. What is the ratio of the Unemployed and educated male labor force (% of population) of OECD members in 2003 to that in 2005?
Provide a short and direct response. 1. What is the ratio of the Unemployed and educated male labor force (% of population) of Bahrain in 2003 to that in 2005?
Give a very brief answer. 1.07. What is the ratio of the Unemployed and educated male labor force (% of population) of Croatia in 2003 to that in 2005?
Offer a very short reply. 1.27. What is the ratio of the Unemployed and educated male labor force (% of population) of Kazakhstan in 2003 to that in 2005?
Provide a short and direct response. 1.09. What is the ratio of the Unemployed and educated male labor force (% of population) of OECD members in 2003 to that in 2006?
Make the answer very short. 1. What is the ratio of the Unemployed and educated male labor force (% of population) in Bahrain in 2003 to that in 2006?
Make the answer very short. 1.57. What is the ratio of the Unemployed and educated male labor force (% of population) of Croatia in 2003 to that in 2006?
Provide a succinct answer. 1.05. What is the ratio of the Unemployed and educated male labor force (% of population) in Kazakhstan in 2003 to that in 2006?
Your answer should be compact. 1.12. What is the ratio of the Unemployed and educated male labor force (% of population) of OECD members in 2003 to that in 2007?
Ensure brevity in your answer.  0.99. What is the ratio of the Unemployed and educated male labor force (% of population) in Bahrain in 2003 to that in 2007?
Your response must be concise. 1.67. What is the ratio of the Unemployed and educated male labor force (% of population) in Croatia in 2003 to that in 2007?
Your answer should be very brief. 1.05. What is the ratio of the Unemployed and educated male labor force (% of population) of Kazakhstan in 2003 to that in 2007?
Ensure brevity in your answer.  1.12. What is the ratio of the Unemployed and educated male labor force (% of population) in OECD members in 2004 to that in 2005?
Your response must be concise. 1. What is the ratio of the Unemployed and educated male labor force (% of population) in Bahrain in 2004 to that in 2005?
Your answer should be compact. 1.02. What is the ratio of the Unemployed and educated male labor force (% of population) in Croatia in 2004 to that in 2005?
Your answer should be very brief. 1.17. What is the ratio of the Unemployed and educated male labor force (% of population) of Kazakhstan in 2004 to that in 2005?
Offer a terse response. 1.03. What is the ratio of the Unemployed and educated male labor force (% of population) in Bahrain in 2004 to that in 2006?
Make the answer very short. 1.5. What is the ratio of the Unemployed and educated male labor force (% of population) in Kazakhstan in 2004 to that in 2006?
Your answer should be compact. 1.06. What is the ratio of the Unemployed and educated male labor force (% of population) in OECD members in 2004 to that in 2007?
Keep it short and to the point. 0.98. What is the ratio of the Unemployed and educated male labor force (% of population) of Bahrain in 2004 to that in 2007?
Give a very brief answer. 1.6. What is the ratio of the Unemployed and educated male labor force (% of population) of Kazakhstan in 2004 to that in 2007?
Your response must be concise. 1.06. What is the ratio of the Unemployed and educated male labor force (% of population) in Bahrain in 2005 to that in 2006?
Offer a very short reply. 1.47. What is the ratio of the Unemployed and educated male labor force (% of population) in Croatia in 2005 to that in 2006?
Your response must be concise. 0.83. What is the ratio of the Unemployed and educated male labor force (% of population) in Kazakhstan in 2005 to that in 2006?
Make the answer very short. 1.03. What is the ratio of the Unemployed and educated male labor force (% of population) in OECD members in 2005 to that in 2007?
Your response must be concise. 0.99. What is the ratio of the Unemployed and educated male labor force (% of population) of Bahrain in 2005 to that in 2007?
Your response must be concise. 1.56. What is the ratio of the Unemployed and educated male labor force (% of population) of Croatia in 2005 to that in 2007?
Provide a short and direct response. 0.83. What is the ratio of the Unemployed and educated male labor force (% of population) of Kazakhstan in 2005 to that in 2007?
Offer a very short reply. 1.03. What is the ratio of the Unemployed and educated male labor force (% of population) in OECD members in 2006 to that in 2007?
Make the answer very short. 0.98. What is the ratio of the Unemployed and educated male labor force (% of population) in Bahrain in 2006 to that in 2007?
Provide a short and direct response. 1.06. What is the ratio of the Unemployed and educated male labor force (% of population) of Croatia in 2006 to that in 2007?
Offer a very short reply. 1. What is the ratio of the Unemployed and educated male labor force (% of population) of Kazakhstan in 2006 to that in 2007?
Provide a short and direct response. 1. What is the difference between the highest and the second highest Unemployed and educated male labor force (% of population) of OECD members?
Give a very brief answer. 0.87. What is the difference between the highest and the second highest Unemployed and educated male labor force (% of population) of Croatia?
Your response must be concise. 1.2. What is the difference between the highest and the lowest Unemployed and educated male labor force (% of population) of OECD members?
Your answer should be compact. 1.52. What is the difference between the highest and the lowest Unemployed and educated male labor force (% of population) of Bahrain?
Provide a short and direct response. 20.7. What is the difference between the highest and the lowest Unemployed and educated male labor force (% of population) in Croatia?
Make the answer very short. 5.8. 